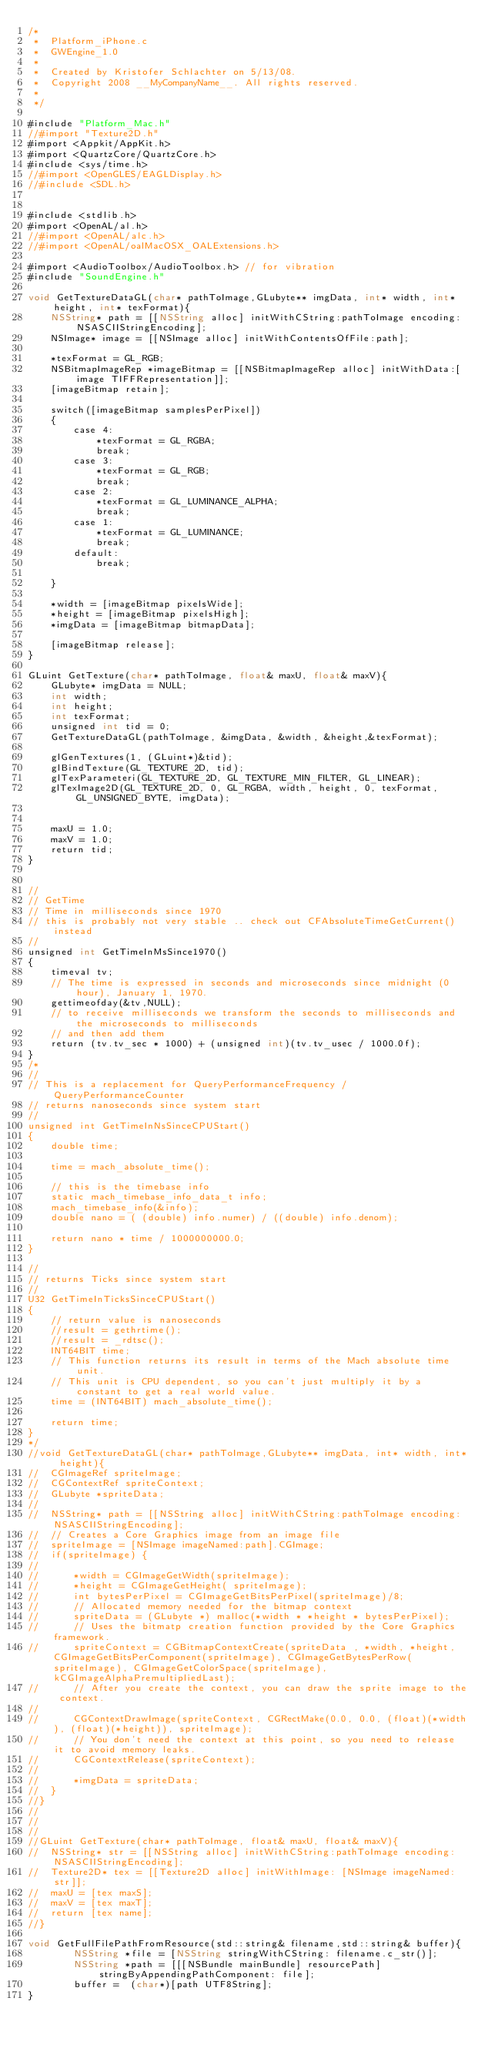Convert code to text. <code><loc_0><loc_0><loc_500><loc_500><_ObjectiveC_>/*
 *  Platform_iPhone.c
 *  GWEngine_1.0
 *
 *  Created by Kristofer Schlachter on 5/13/08.
 *  Copyright 2008 __MyCompanyName__. All rights reserved.
 *
 */

#include "Platform_Mac.h"
//#import "Texture2D.h"
#import <Appkit/AppKit.h>
#import <QuartzCore/QuartzCore.h>
#include <sys/time.h>
//#import <OpenGLES/EAGLDisplay.h>
//#include <SDL.h>


#include <stdlib.h>
#import <OpenAL/al.h>
//#import <OpenAL/alc.h>
//#import <OpenAL/oalMacOSX_OALExtensions.h>

#import <AudioToolbox/AudioToolbox.h> // for vibration
#include "SoundEngine.h"

void GetTextureDataGL(char* pathToImage,GLubyte** imgData, int* width, int* height, int* texFormat){
	NSString* path = [[NSString alloc] initWithCString:pathToImage encoding:NSASCIIStringEncoding];
	NSImage* image = [[NSImage alloc] initWithContentsOfFile:path];
	
	*texFormat = GL_RGB;
	NSBitmapImageRep *imageBitmap = [[NSBitmapImageRep alloc] initWithData:[image TIFFRepresentation]];
	[imageBitmap retain];
	
	switch([imageBitmap samplesPerPixel])
	{
		case 4:
			*texFormat = GL_RGBA;
			break;
		case 3:
			*texFormat = GL_RGB;
			break;
		case 2:
			*texFormat = GL_LUMINANCE_ALPHA;
			break;
		case 1:
			*texFormat = GL_LUMINANCE;
			break;
		default:
			break;
			
	}
	
	*width = [imageBitmap pixelsWide];
	*height = [imageBitmap pixelsHigh];
	*imgData = [imageBitmap bitmapData];
	
	[imageBitmap release];
}

GLuint GetTexture(char* pathToImage, float& maxU, float& maxV){
	GLubyte* imgData = NULL;
	int width;
	int height;
	int texFormat;
	unsigned int tid = 0;
	GetTextureDataGL(pathToImage, &imgData, &width, &height,&texFormat);
	
	glGenTextures(1, (GLuint*)&tid);
	glBindTexture(GL_TEXTURE_2D, tid);
	glTexParameteri(GL_TEXTURE_2D, GL_TEXTURE_MIN_FILTER, GL_LINEAR);
	glTexImage2D(GL_TEXTURE_2D, 0, GL_RGBA, width, height, 0, texFormat, GL_UNSIGNED_BYTE, imgData);
	
	
	maxU = 1.0;
	maxV = 1.0;
	return tid;
}	


// 
// GetTime
// Time in milliseconds since 1970
// this is probably not very stable .. check out CFAbsoluteTimeGetCurrent() instead
//
unsigned int GetTimeInMsSince1970()
{
	timeval tv;
	// The time is expressed in seconds and microseconds since midnight (0 hour), January 1, 1970.
	gettimeofday(&tv,NULL);
	// to receive milliseconds we transform the seconds to milliseconds and the microseconds to milliseconds
	// and then add them
	return (tv.tv_sec * 1000) + (unsigned int)(tv.tv_usec / 1000.0f);
}
/*
//
// This is a replacement for QueryPerformanceFrequency / QueryPerformanceCounter
// returns nanoseconds since system start
//
unsigned int GetTimeInNsSinceCPUStart()
{
	double time;
	
	time = mach_absolute_time();
	
	// this is the timebase info
    static mach_timebase_info_data_t info;
    mach_timebase_info(&info);
    double nano = ( (double) info.numer) / ((double) info.denom);
	
	return nano * time / 1000000000.0;
}

//
// returns Ticks since system start
//
U32 GetTimeInTicksSinceCPUStart()
{
	// return value is nanoseconds
	//result = gethrtime();
	//result = _rdtsc();
	INT64BIT time;
	// This function returns its result in terms of the Mach absolute time unit. 
	// This unit is CPU dependent, so you can't just multiply it by a constant to get a real world value. 
	time = (INT64BIT) mach_absolute_time();
	
	return time;
}
*/
//void GetTextureDataGL(char* pathToImage,GLubyte** imgData, int* width, int* height){
//	CGImageRef spriteImage;
//	CGContextRef spriteContext;
//	GLubyte *spriteData;
//
//	NSString* path = [[NSString alloc] initWithCString:pathToImage encoding:NSASCIIStringEncoding];
//	// Creates a Core Graphics image from an image file
//	spriteImage = [NSImage imageNamed:path].CGImage;
//	if(spriteImage) {
//		
//		*width = CGImageGetWidth(spriteImage);
//		*height = CGImageGetHeight( spriteImage);
//		int bytesPerPixel = CGImageGetBitsPerPixel(spriteImage)/8;
//		// Allocated memory needed for the bitmap context
//		spriteData = (GLubyte *) malloc(*width * *height * bytesPerPixel);
//		// Uses the bitmatp creation function provided by the Core Graphics framework. 
//		spriteContext = CGBitmapContextCreate(spriteData , *width, *height,CGImageGetBitsPerComponent(spriteImage), CGImageGetBytesPerRow(spriteImage), CGImageGetColorSpace(spriteImage), kCGImageAlphaPremultipliedLast);
//		// After you create the context, you can draw the sprite image to the context.
//		
//		CGContextDrawImage(spriteContext, CGRectMake(0.0, 0.0, (float)(*width), (float)(*height)), spriteImage);
//		// You don't need the context at this point, so you need to release it to avoid memory leaks.
//		CGContextRelease(spriteContext);
//		
//		*imgData = spriteData;
//	}
//}
//
//
//
//GLuint GetTexture(char* pathToImage, float& maxU, float& maxV){
//	NSString* str = [[NSString alloc] initWithCString:pathToImage encoding:NSASCIIStringEncoding];
//	Texture2D* tex = [[Texture2D alloc] initWithImage: [NSImage imageNamed:str]];
//	maxU = [tex maxS];
//	maxV = [tex maxT];
//	return [tex name];
//}	

void GetFullFilePathFromResource(std::string& filename,std::string& buffer){
		NSString *file = [NSString stringWithCString: filename.c_str()];
		NSString *path = [[[NSBundle mainBundle] resourcePath] stringByAppendingPathComponent: file];
		buffer =  (char*)[path UTF8String];
}
</code> 